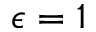Convert formula to latex. <formula><loc_0><loc_0><loc_500><loc_500>\epsilon = 1</formula> 